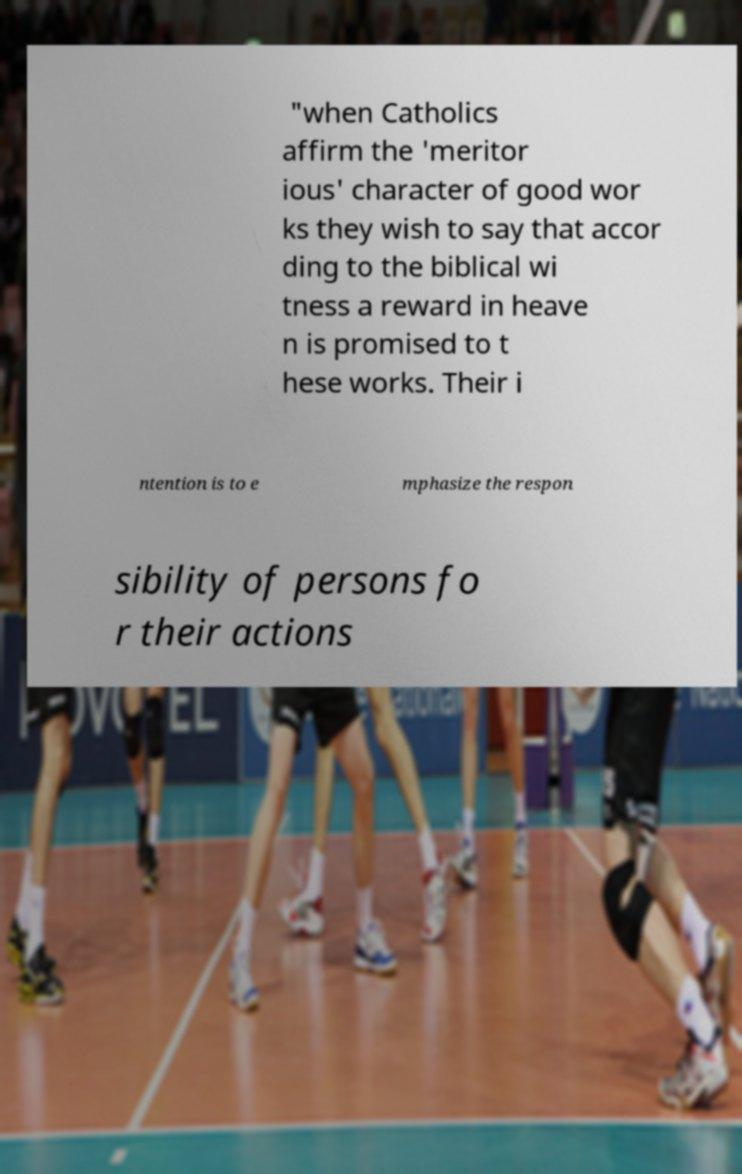Please identify and transcribe the text found in this image. "when Catholics affirm the 'meritor ious' character of good wor ks they wish to say that accor ding to the biblical wi tness a reward in heave n is promised to t hese works. Their i ntention is to e mphasize the respon sibility of persons fo r their actions 